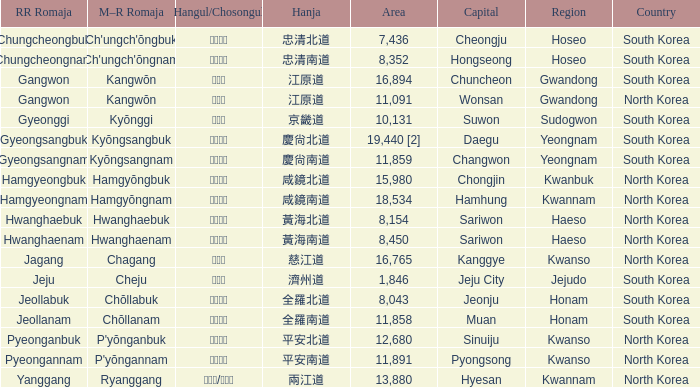Which capital has a Hangul of 경상남도? Changwon. 